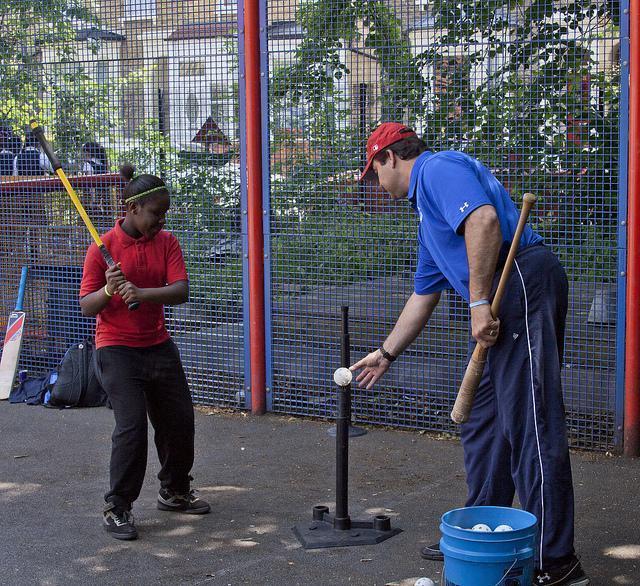What is the black pole the white ball is on called?
From the following four choices, select the correct answer to address the question.
Options: Steady hit, batting tee, pitcher's mound, street pole. Batting tee. 